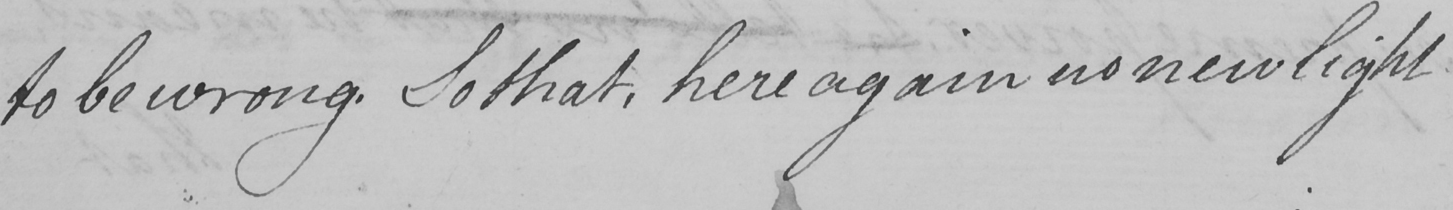Please provide the text content of this handwritten line. to be wrong. So that, here again no new light 